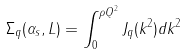<formula> <loc_0><loc_0><loc_500><loc_500>\Sigma _ { q } ( \alpha _ { s } , L ) = \int _ { 0 } ^ { \rho Q ^ { 2 } } J _ { q } ( k ^ { 2 } ) d k ^ { 2 }</formula> 